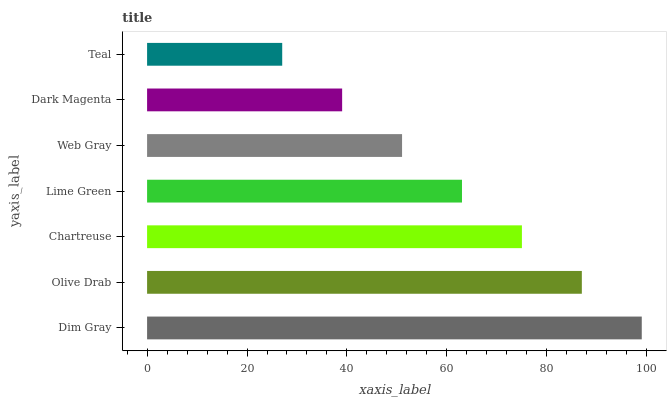Is Teal the minimum?
Answer yes or no. Yes. Is Dim Gray the maximum?
Answer yes or no. Yes. Is Olive Drab the minimum?
Answer yes or no. No. Is Olive Drab the maximum?
Answer yes or no. No. Is Dim Gray greater than Olive Drab?
Answer yes or no. Yes. Is Olive Drab less than Dim Gray?
Answer yes or no. Yes. Is Olive Drab greater than Dim Gray?
Answer yes or no. No. Is Dim Gray less than Olive Drab?
Answer yes or no. No. Is Lime Green the high median?
Answer yes or no. Yes. Is Lime Green the low median?
Answer yes or no. Yes. Is Web Gray the high median?
Answer yes or no. No. Is Olive Drab the low median?
Answer yes or no. No. 